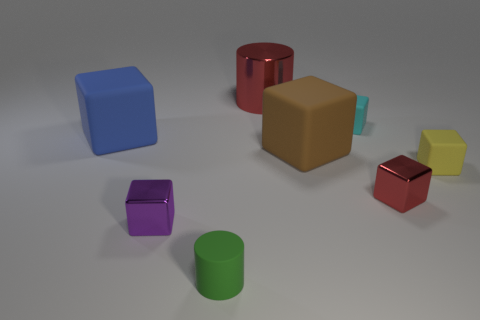How many green objects are right of the small cube that is behind the large blue rubber cube?
Provide a short and direct response. 0. What is the large cylinder made of?
Offer a terse response. Metal. How many purple objects are behind the tiny yellow block?
Your answer should be compact. 0. Is the large shiny cylinder the same color as the matte cylinder?
Ensure brevity in your answer.  No. What number of shiny cubes have the same color as the tiny rubber cylinder?
Keep it short and to the point. 0. Are there more tiny purple metallic objects than rubber things?
Offer a terse response. No. How big is the block that is in front of the small yellow rubber cube and on the left side of the large red thing?
Provide a short and direct response. Small. Are the cylinder behind the yellow rubber object and the cylinder in front of the cyan matte cube made of the same material?
Keep it short and to the point. No. There is a red metal object that is the same size as the brown block; what shape is it?
Provide a succinct answer. Cylinder. Are there fewer cubes than tiny green cylinders?
Your answer should be very brief. No. 